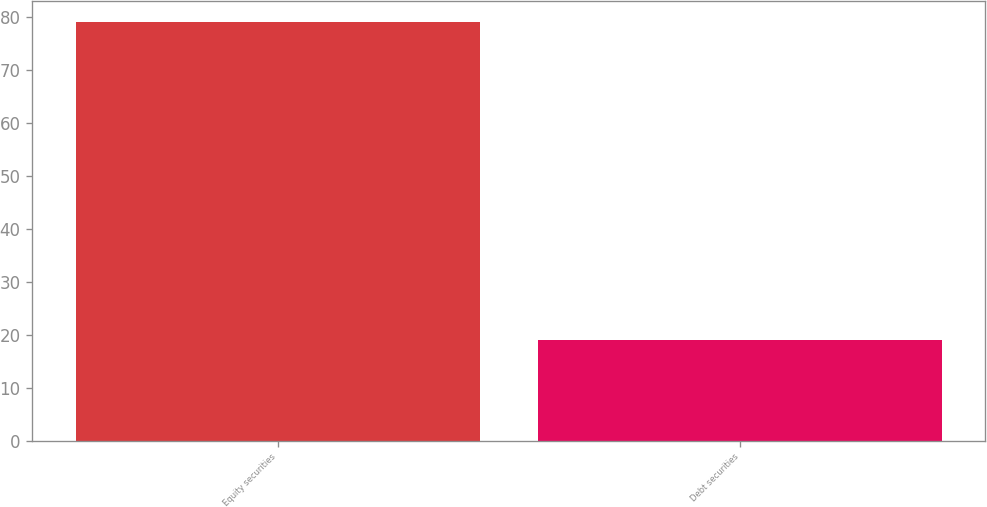Convert chart to OTSL. <chart><loc_0><loc_0><loc_500><loc_500><bar_chart><fcel>Equity securities<fcel>Debt securities<nl><fcel>79<fcel>19<nl></chart> 